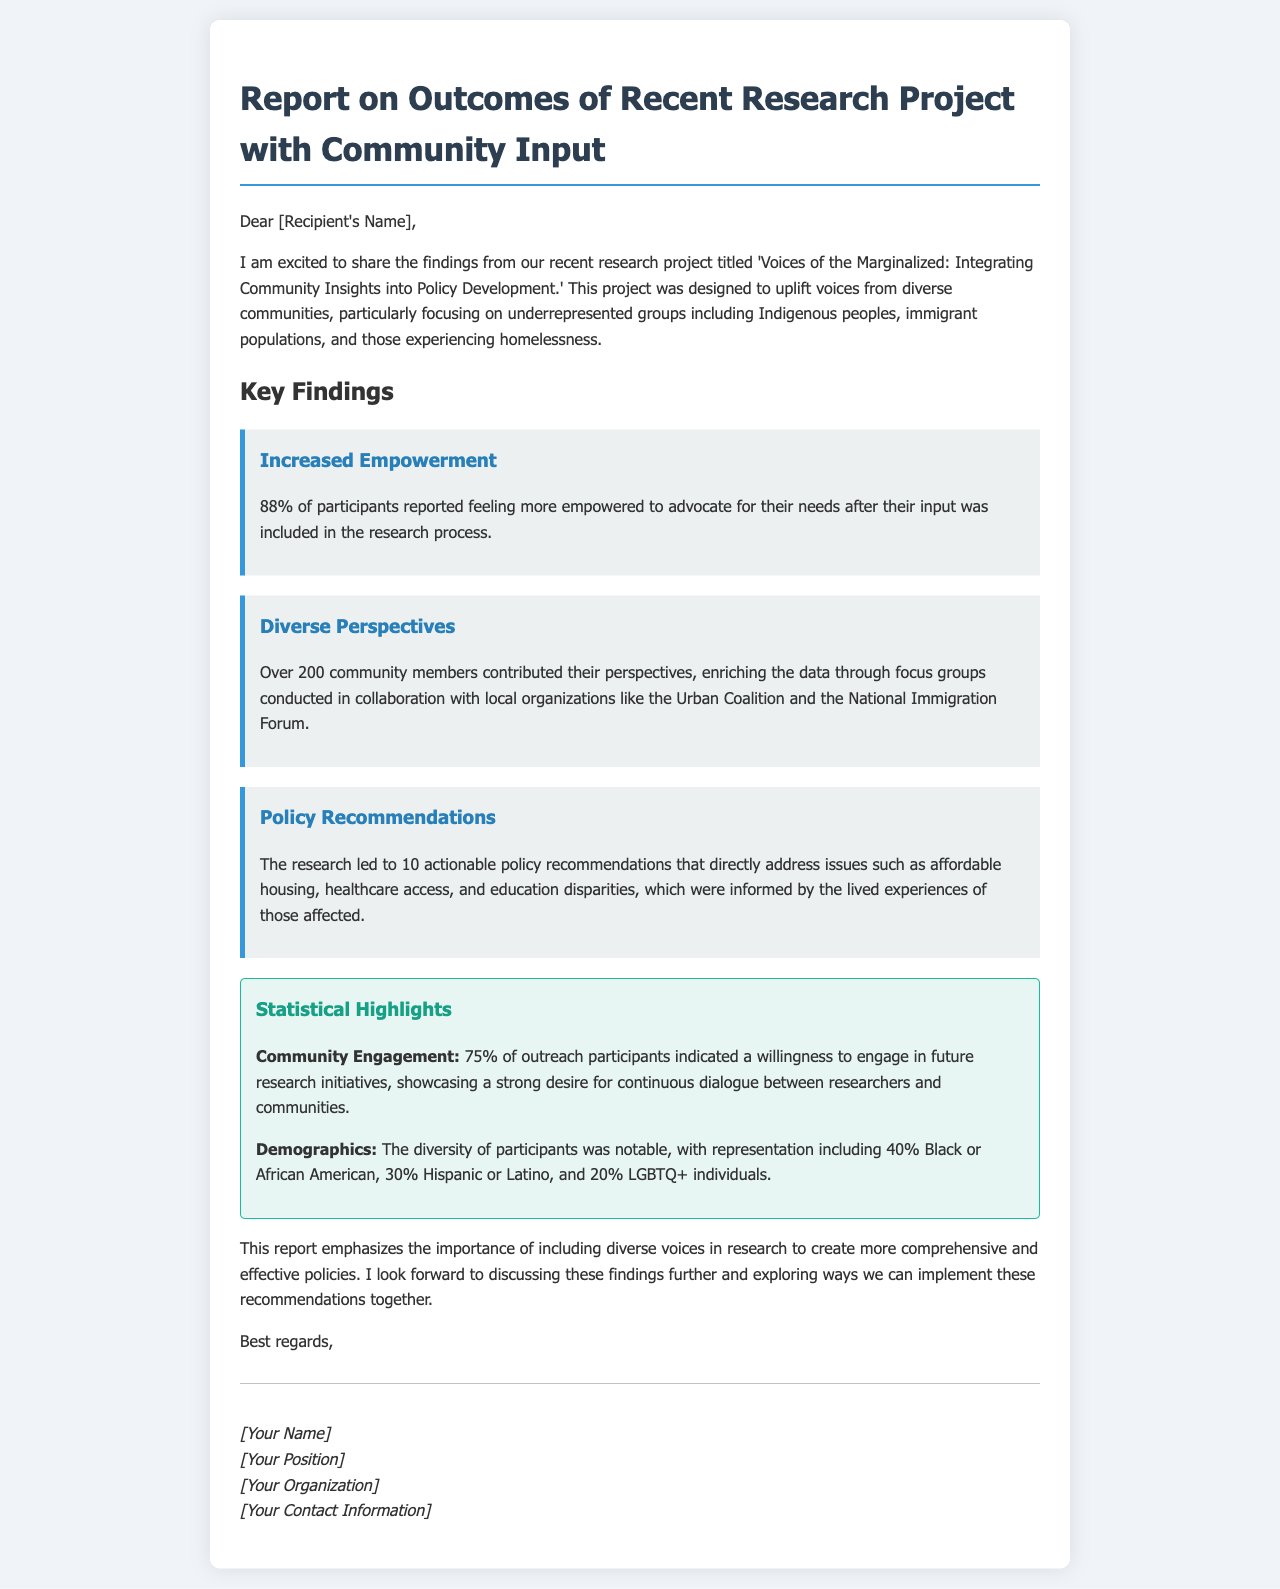what is the title of the research project? The title of the research project is found in the opening paragraph of the document.
Answer: Voices of the Marginalized: Integrating Community Insights into Policy Development what percentage of participants reported feeling more empowered? The percentage is stated in the key finding about increased empowerment.
Answer: 88% how many community members contributed their perspectives? The number of community members is mentioned in the key finding about diverse perspectives.
Answer: Over 200 how many policy recommendations were made? The number of policy recommendations is disclosed in the key finding on policy recommendations.
Answer: 10 what percentage of outreach participants indicated willingness for future engagement? This statistic is part of the statistical highlights regarding community engagement.
Answer: 75% which local organization was mentioned in collaboration? The document mentions a specific organization that collaborated in the research.
Answer: Urban Coalition what demographic percentage represents Black or African American? The demographic breakdown provides specific percentages for various groups.
Answer: 40% why is including diverse voices important according to the report? This reasoning is found in the conclusion paragraph of the document.
Answer: To create more comprehensive and effective policies who is the sender of the report? The sender is identified in the signature at the end of the document.
Answer: [Your Name] 